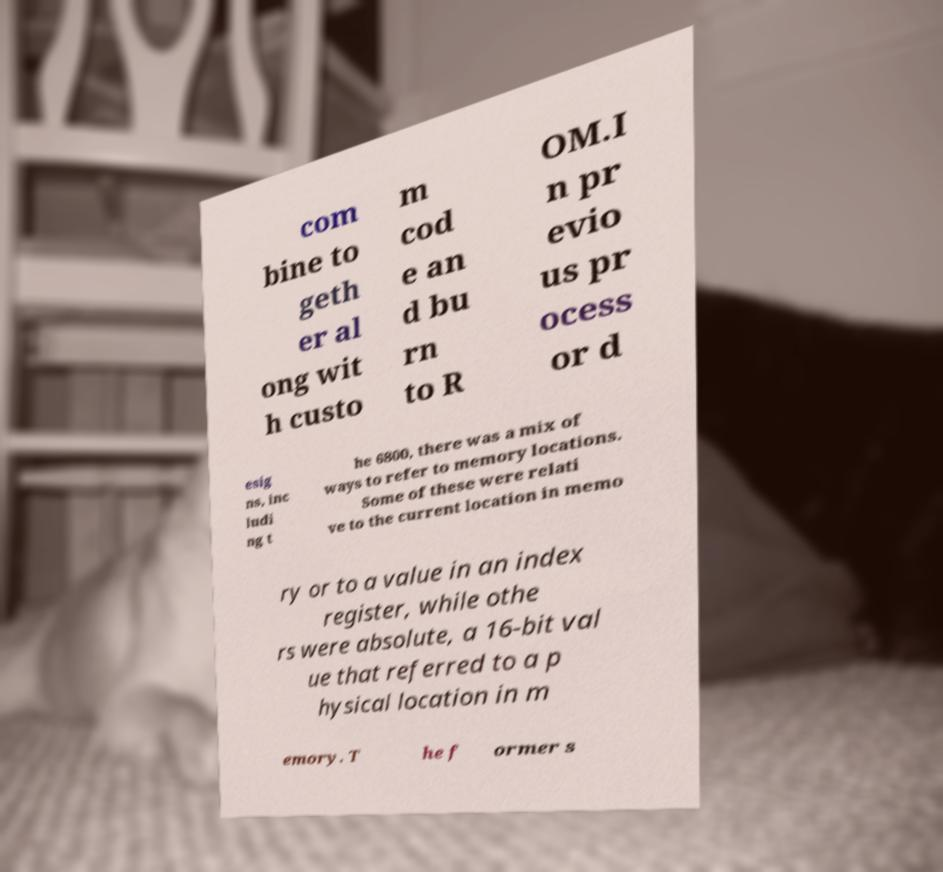I need the written content from this picture converted into text. Can you do that? com bine to geth er al ong wit h custo m cod e an d bu rn to R OM.I n pr evio us pr ocess or d esig ns, inc ludi ng t he 6800, there was a mix of ways to refer to memory locations. Some of these were relati ve to the current location in memo ry or to a value in an index register, while othe rs were absolute, a 16-bit val ue that referred to a p hysical location in m emory. T he f ormer s 